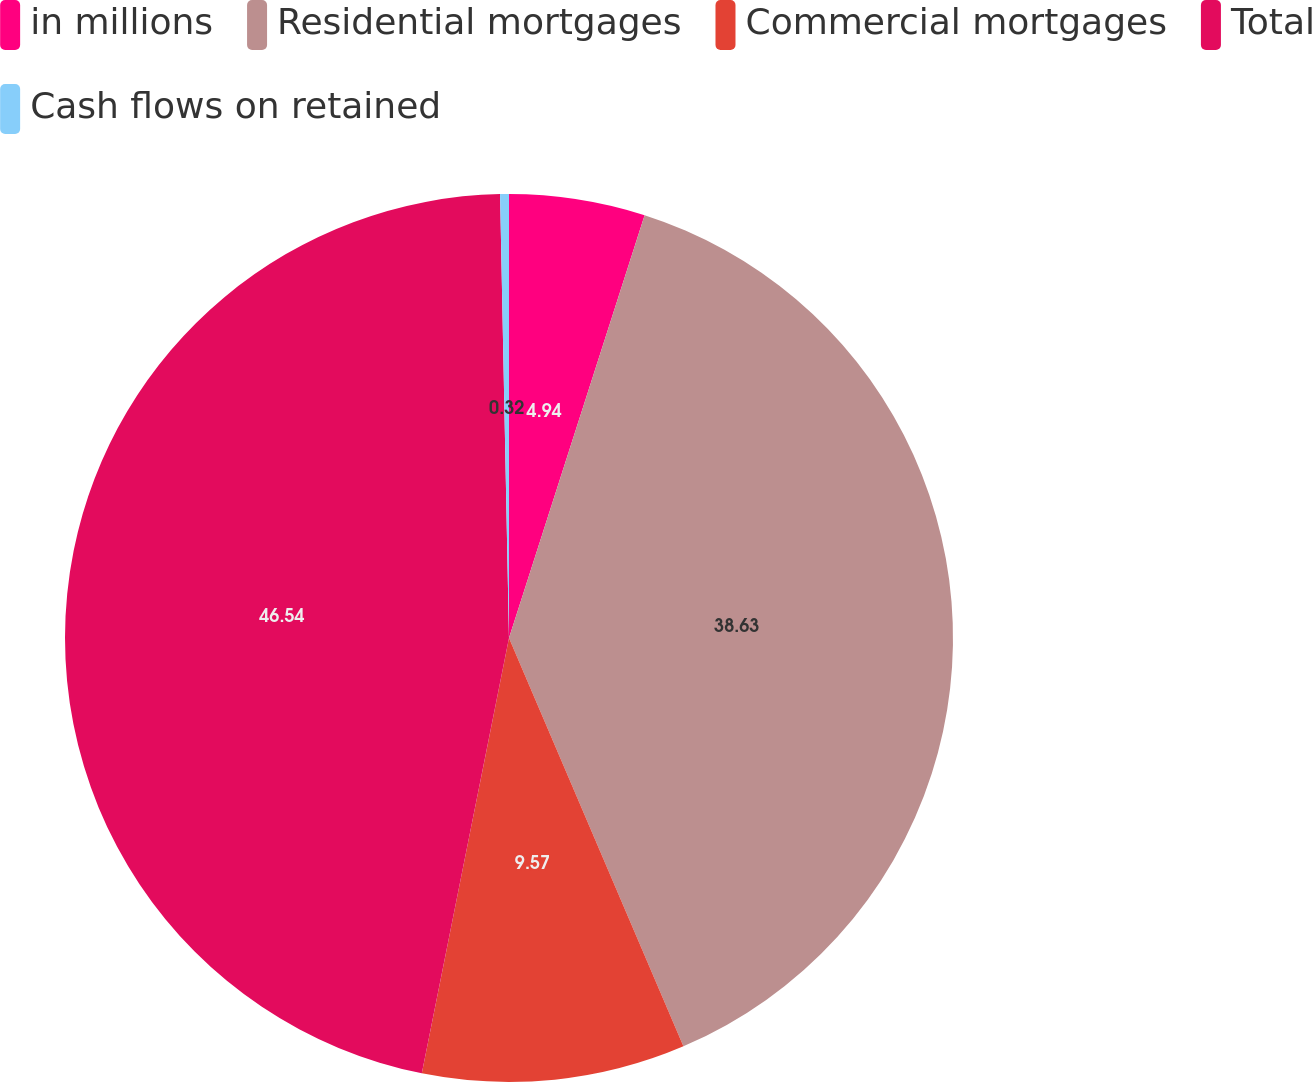<chart> <loc_0><loc_0><loc_500><loc_500><pie_chart><fcel>in millions<fcel>Residential mortgages<fcel>Commercial mortgages<fcel>Total<fcel>Cash flows on retained<nl><fcel>4.94%<fcel>38.63%<fcel>9.57%<fcel>46.53%<fcel>0.32%<nl></chart> 